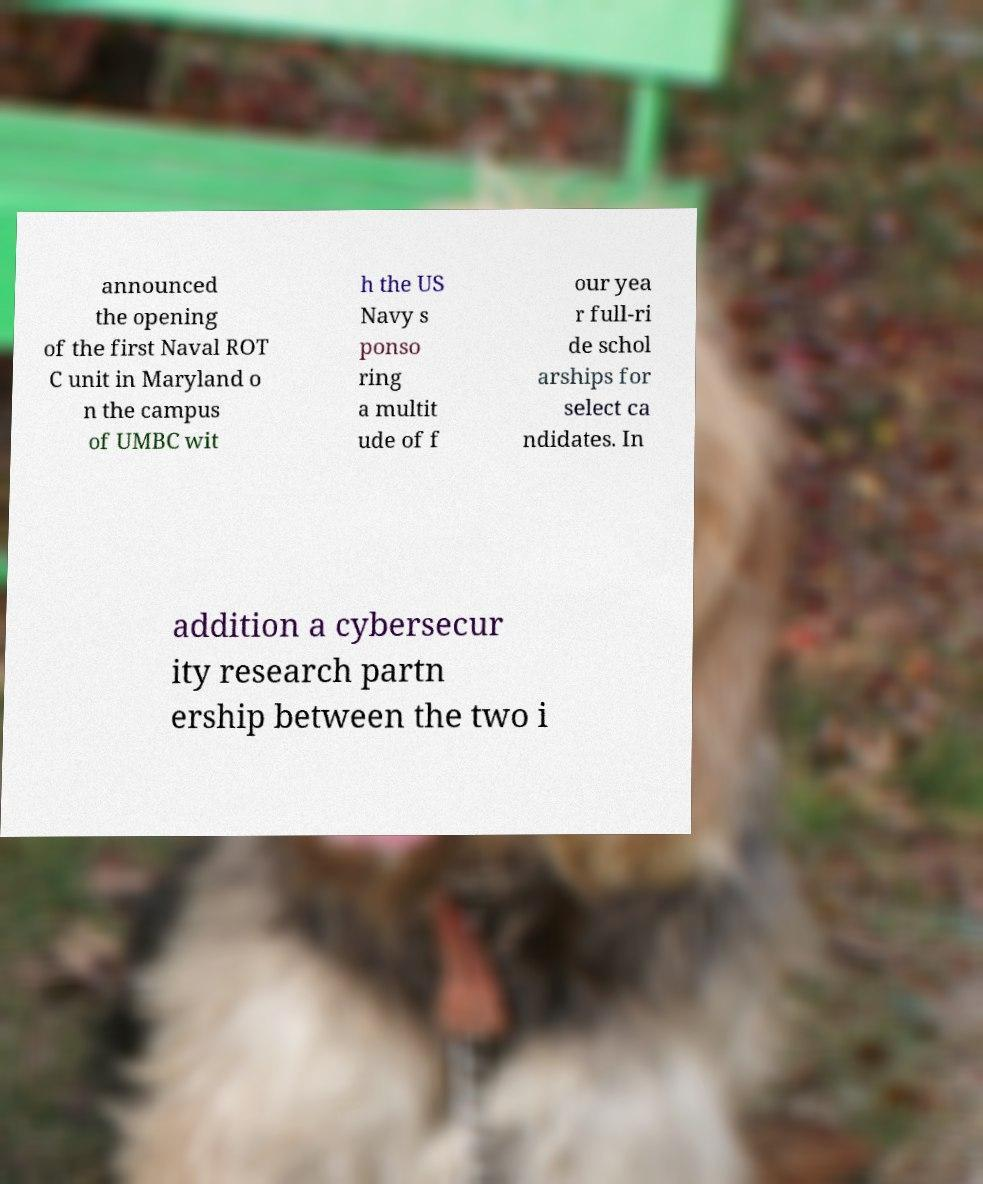What messages or text are displayed in this image? I need them in a readable, typed format. announced the opening of the first Naval ROT C unit in Maryland o n the campus of UMBC wit h the US Navy s ponso ring a multit ude of f our yea r full-ri de schol arships for select ca ndidates. In addition a cybersecur ity research partn ership between the two i 